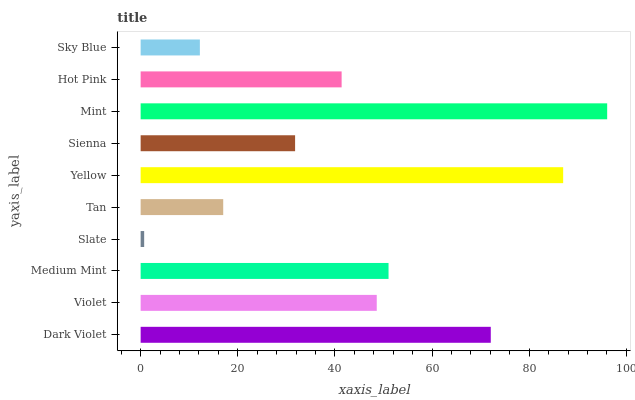Is Slate the minimum?
Answer yes or no. Yes. Is Mint the maximum?
Answer yes or no. Yes. Is Violet the minimum?
Answer yes or no. No. Is Violet the maximum?
Answer yes or no. No. Is Dark Violet greater than Violet?
Answer yes or no. Yes. Is Violet less than Dark Violet?
Answer yes or no. Yes. Is Violet greater than Dark Violet?
Answer yes or no. No. Is Dark Violet less than Violet?
Answer yes or no. No. Is Violet the high median?
Answer yes or no. Yes. Is Hot Pink the low median?
Answer yes or no. Yes. Is Medium Mint the high median?
Answer yes or no. No. Is Slate the low median?
Answer yes or no. No. 